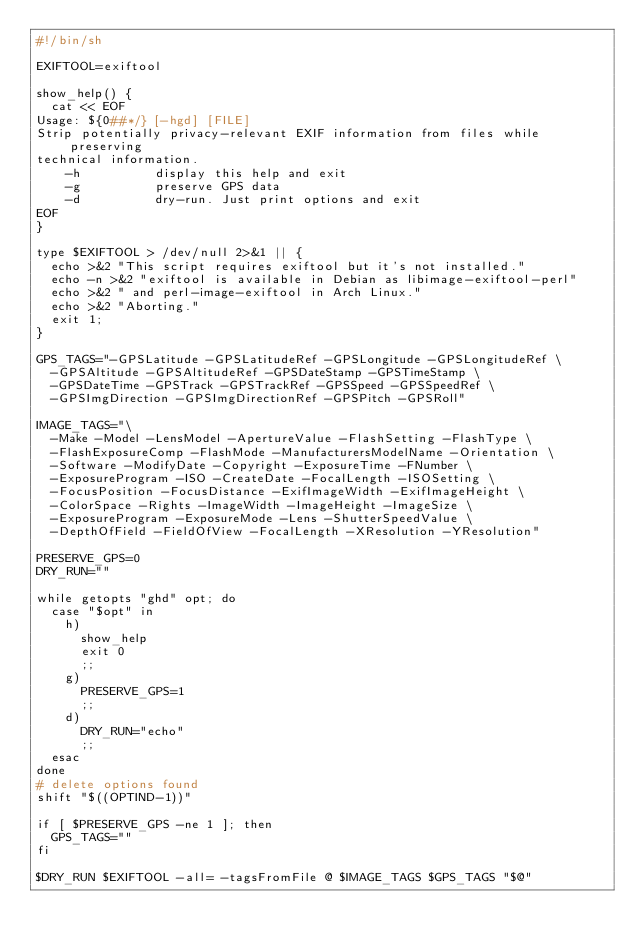<code> <loc_0><loc_0><loc_500><loc_500><_Bash_>#!/bin/sh

EXIFTOOL=exiftool

show_help() {
	cat << EOF
Usage: ${0##*/} [-hgd] [FILE]
Strip potentially privacy-relevant EXIF information from files while preserving
technical information.
    -h          display this help and exit
    -g          preserve GPS data
    -d          dry-run. Just print options and exit
EOF
}

type $EXIFTOOL > /dev/null 2>&1 || {
	echo >&2 "This script requires exiftool but it's not installed."
	echo -n >&2 "exiftool is available in Debian as libimage-exiftool-perl"
	echo >&2 " and perl-image-exiftool in Arch Linux."
	echo >&2 "Aborting."
	exit 1;
}

GPS_TAGS="-GPSLatitude -GPSLatitudeRef -GPSLongitude -GPSLongitudeRef \
	-GPSAltitude -GPSAltitudeRef -GPSDateStamp -GPSTimeStamp \
	-GPSDateTime -GPSTrack -GPSTrackRef -GPSSpeed -GPSSpeedRef \
	-GPSImgDirection -GPSImgDirectionRef -GPSPitch -GPSRoll"

IMAGE_TAGS="\
	-Make -Model -LensModel -ApertureValue -FlashSetting -FlashType \
	-FlashExposureComp -FlashMode -ManufacturersModelName -Orientation \
	-Software -ModifyDate -Copyright -ExposureTime -FNumber \
	-ExposureProgram -ISO -CreateDate -FocalLength -ISOSetting \
	-FocusPosition -FocusDistance -ExifImageWidth -ExifImageHeight \
	-ColorSpace -Rights -ImageWidth -ImageHeight -ImageSize \
	-ExposureProgram -ExposureMode -Lens -ShutterSpeedValue \
	-DepthOfField -FieldOfView -FocalLength -XResolution -YResolution"

PRESERVE_GPS=0
DRY_RUN=""

while getopts "ghd" opt; do
	case "$opt" in
		h)
			show_help
			exit 0
			;;
		g)
			PRESERVE_GPS=1
			;;
		d)
			DRY_RUN="echo"
			;;
	esac
done
# delete options found
shift "$((OPTIND-1))"

if [ $PRESERVE_GPS -ne 1 ]; then
	GPS_TAGS=""
fi

$DRY_RUN $EXIFTOOL -all= -tagsFromFile @ $IMAGE_TAGS $GPS_TAGS "$@"
</code> 